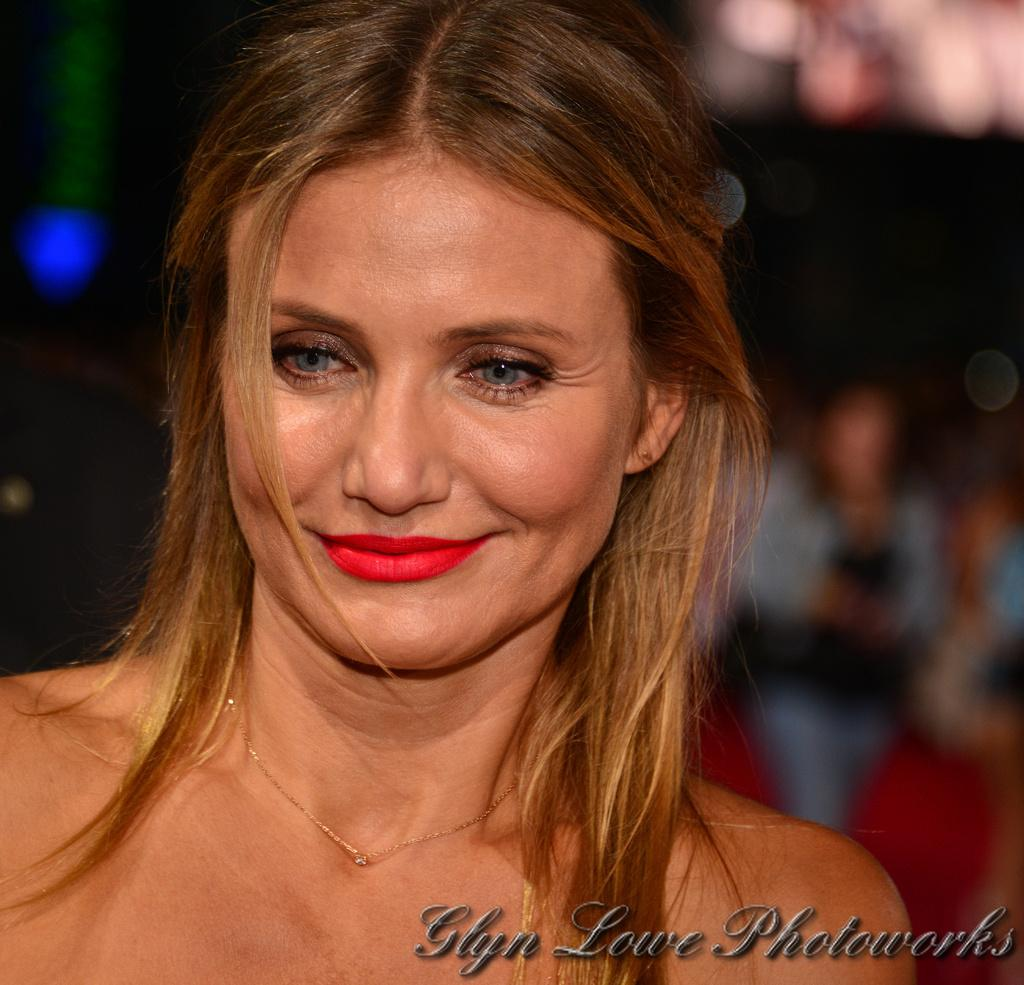Who is present in the image? There is a woman in the image. What is the woman's facial expression? The woman is smiling. What can be found at the bottom of the image? There is text at the bottom of the image. How would you describe the background of the image? The background of the image is blurry. What type of hook can be seen in the woman's hand in the image? There is no hook present in the image; the woman's hands are not visible. 